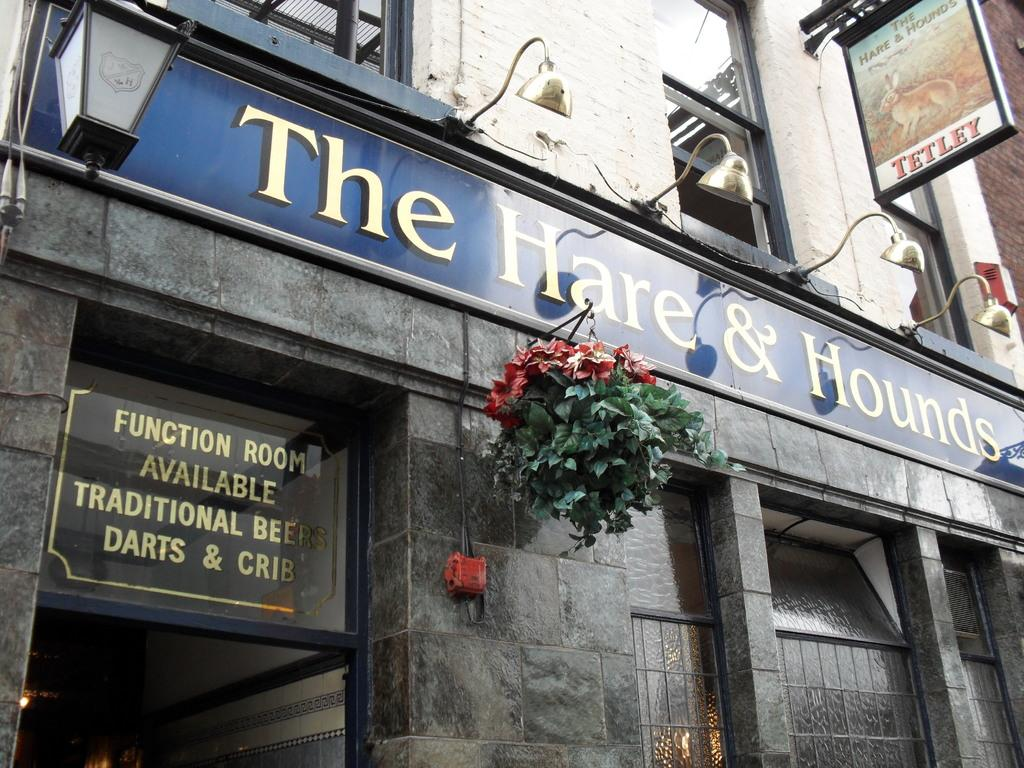<image>
Provide a brief description of the given image. The signage on The Hare & Hounds establishment states there are function rooms available as well as darts. 